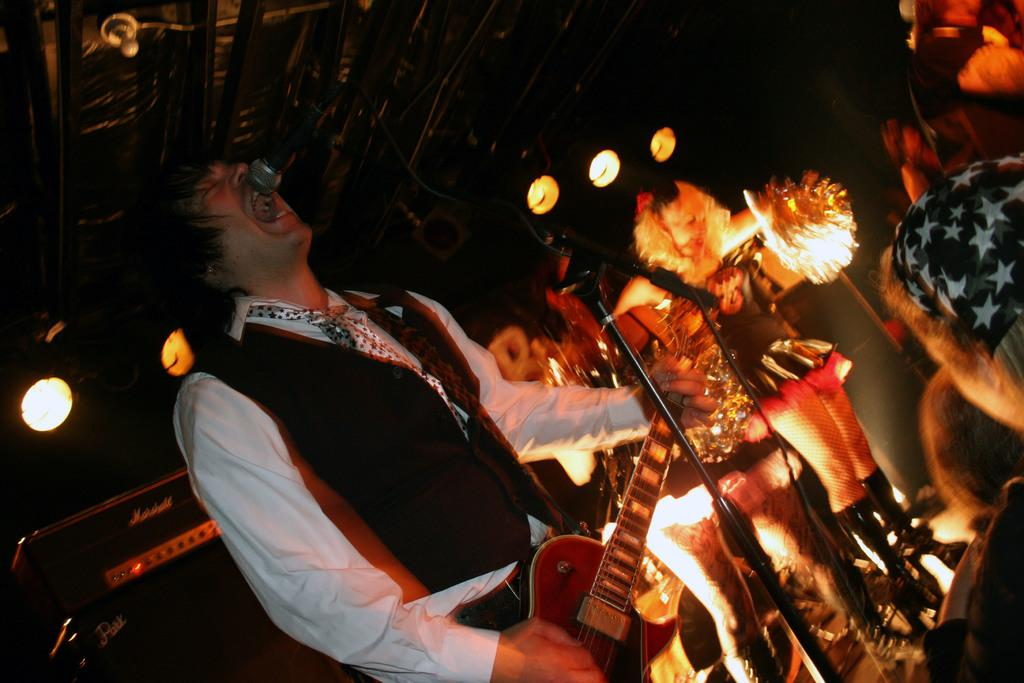What is the man in the image doing? The man is playing the guitar and singing. What instrument is the man using in the image? The man is playing the guitar. Where is the microphone located in relation to the man? The microphone is on the right side of the man. What type of whistle does the man use to accompany his singing in the image? There is no whistle present in the image; the man is using a guitar as his musical instrument. 